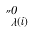Convert formula to latex. <formula><loc_0><loc_0><loc_500><loc_500>\Pi _ { \lambda ( i ) } ^ { 0 }</formula> 